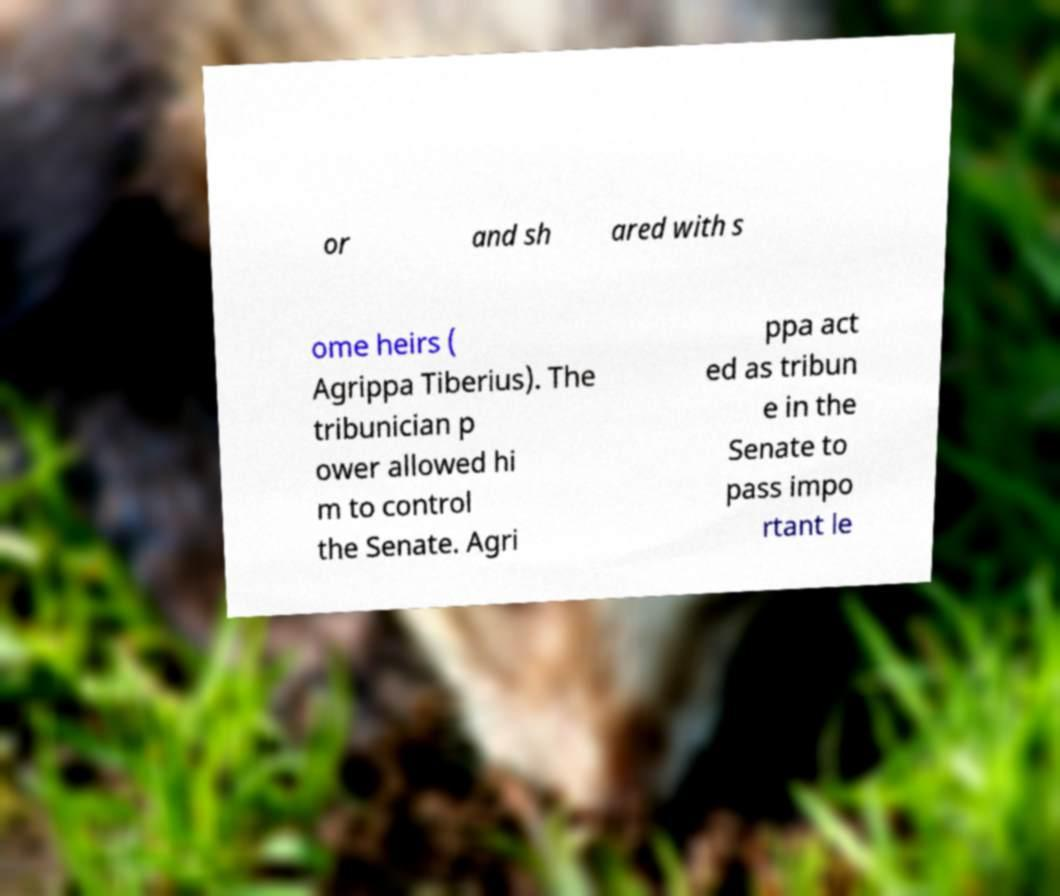What messages or text are displayed in this image? I need them in a readable, typed format. or and sh ared with s ome heirs ( Agrippa Tiberius). The tribunician p ower allowed hi m to control the Senate. Agri ppa act ed as tribun e in the Senate to pass impo rtant le 